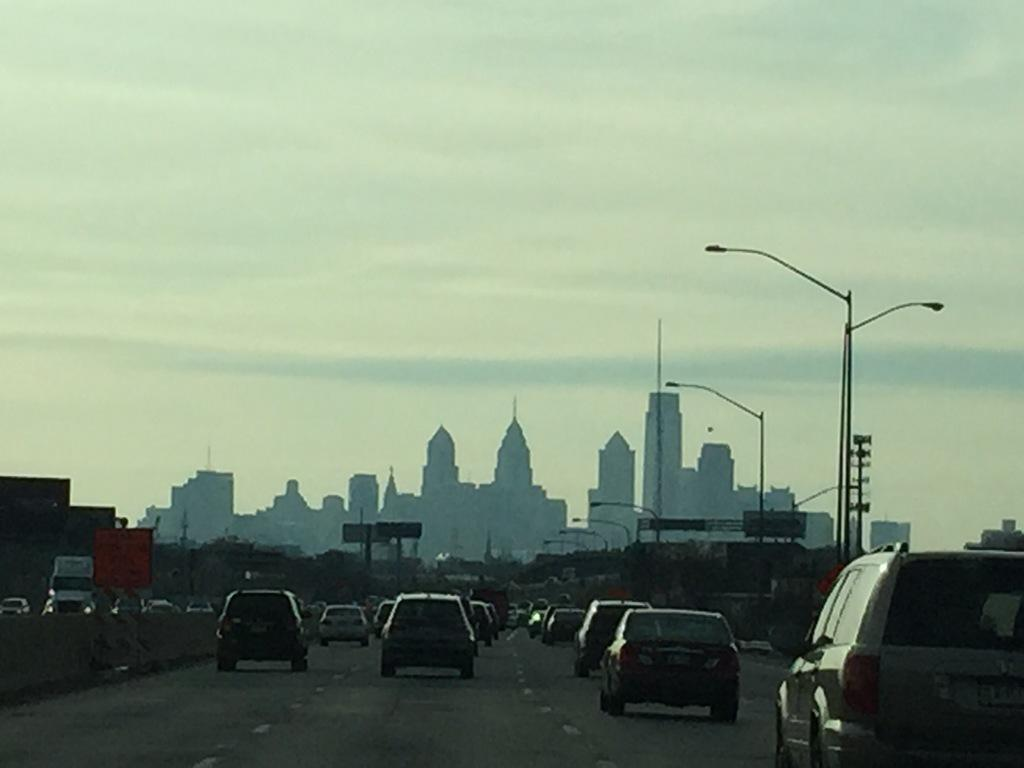What is happening on the road in the image? There are vehicles on the road in the image. Are there any obstructions or restrictions on the road? Yes, there are barricades on the road in the image. What can be seen besides the road and vehicles? There are sign boards and light poles in the image. What is visible in the background of the image? There are buildings and the sky visible in the background of the image. Can you see any cattle grazing on the side of the road in the image? There are no cattle present in the image. What phase of the moon can be seen in the image? The sky is visible in the background of the image, but there is no moon present. 